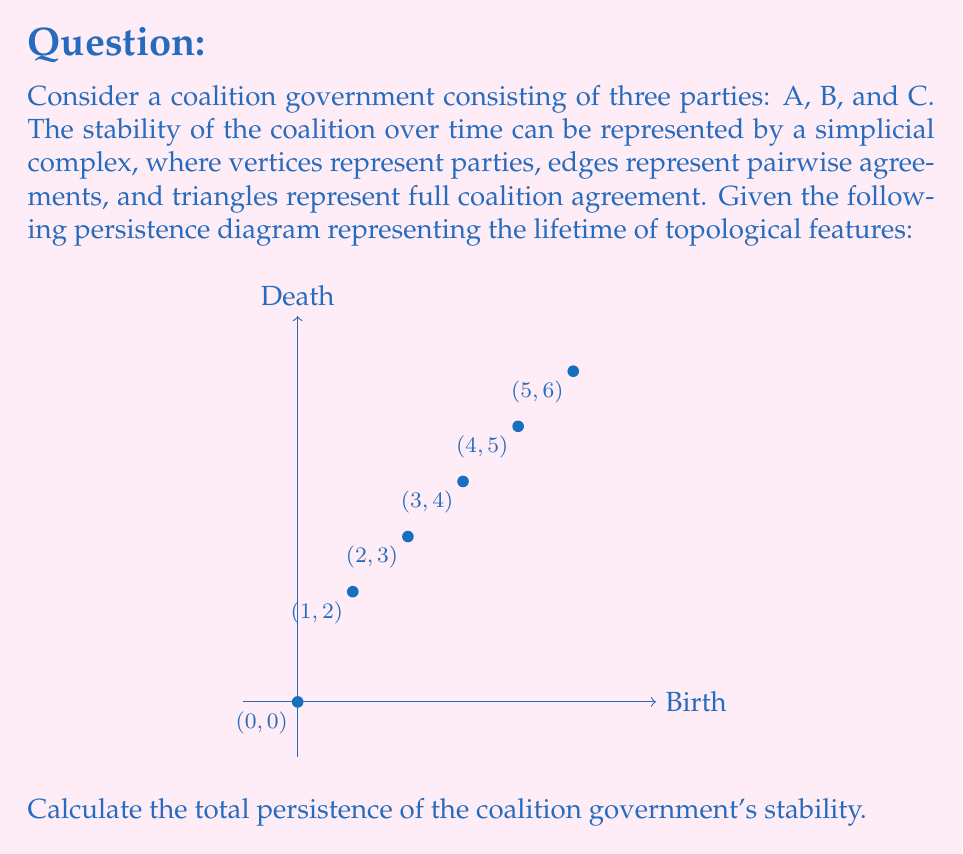Can you answer this question? To solve this problem, we need to understand the concept of total persistence in topological data analysis and how it relates to the stability of coalition governments. Let's break it down step-by-step:

1) In topological data analysis, persistence diagrams represent the birth and death times of topological features (e.g., connected components, cycles, voids) across different scales.

2) Each point (b,d) in the persistence diagram represents a feature that was born at time b and died at time d.

3) The persistence of a feature is calculated as d - b.

4) Total persistence is the sum of all individual persistences.

5) In our diagram, we have the following points:
   (0,0), (1,2), (2,3), (3,4), (4,5), (5,6)

6) Let's calculate the persistence for each point:
   (0,0): 0 - 0 = 0
   (1,2): 2 - 1 = 1
   (2,3): 3 - 2 = 1
   (3,4): 4 - 3 = 1
   (4,5): 5 - 4 = 1
   (5,6): 6 - 5 = 1

7) Now, we sum all these persistences:
   $$ \text{Total Persistence} = 0 + 1 + 1 + 1 + 1 + 1 = 5 $$

In the context of coalition stability, a higher total persistence indicates more stable features (agreements) lasting over time, suggesting a more stable coalition government.
Answer: 5 